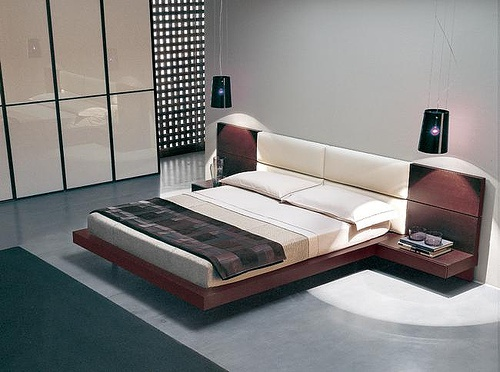Describe the objects in this image and their specific colors. I can see bed in gray, lightgray, black, and tan tones, cup in gray and black tones, book in gray, darkgray, lightgray, and black tones, cup in gray, darkgray, and black tones, and cup in gray, black, and darkgray tones in this image. 